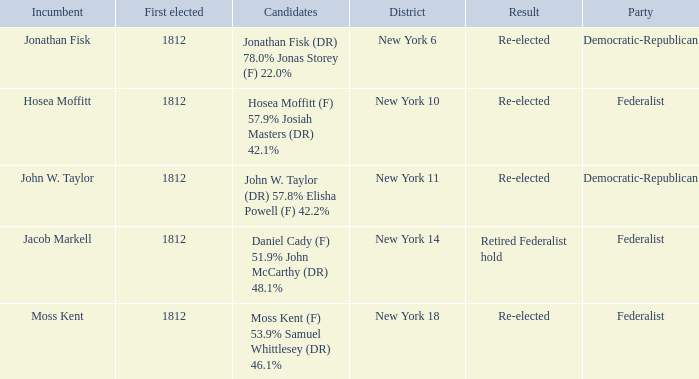Name the first elected for jacob markell 1812.0. 